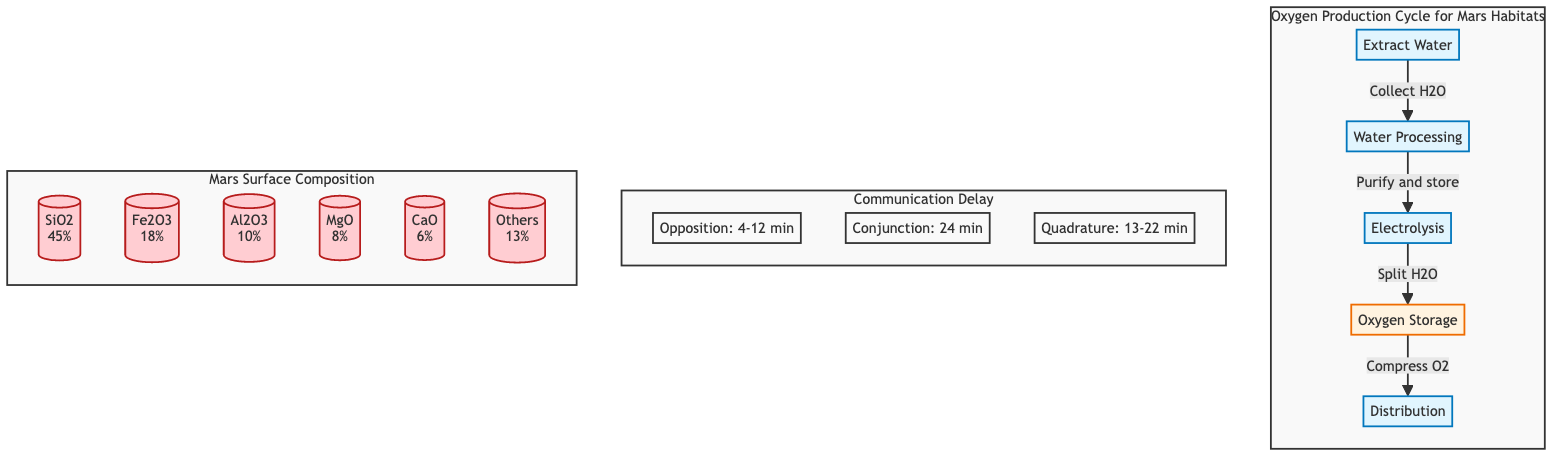What is the first step in the Oxygen Production Cycle? The first step is "Extract Water" which is the starting point of the cycle, initiating the process of obtaining hydrogen and oxygen.
Answer: Extract Water How many processes are involved in the Oxygen Production Cycle for Mars Habitats? There are four main processes; they are "Water Processing," "Electrolysis," "Oxygen Storage," and "Distribution."
Answer: 4 What is the output of the "Electrolysis" node? The output of the "Electrolysis" node is the splitting of H2O, which generates oxygen and hydrogen as byproducts because it specifically refers to the division of water into its elemental components.
Answer: Split H2O At what position does "Oxygen Storage" occur in the cycle? "Oxygen Storage" occurs after "Electrolysis," as indicated by the arrow directing the flow from "Electrolysis" to "Oxygen Storage."
Answer: 3rd What is the communication delay during conjunction? The communication delay during conjunction is 24 minutes according to the specified data in the diagram, representing a situation where Mars and Earth are on opposite sides of the sun.
Answer: 24 min How does "Oxygen Storage" relate to "Distribution"? "Oxygen Storage" leads to "Distribution," meaning that after oxygen is stored, it is then compressed and distributed for use, illustrating a direct flow between these two stages in the oxygen production process.
Answer: Leads to Which mineral has the highest proportion in Mars Surface Composition? The mineral with the highest proportion is SiO2 at 45%, as indicated in the pie chart section of the diagram showing the composition of Martian soil samples.
Answer: SiO2 What is the percentage of Fe2O3 in the Mars Surface Composition? The percentage of Fe2O3 is 18%, which states the specific mineral content in the Martian soil samples examined.
Answer: 18% Which segment of the diagram indicates a higher communication delay: opposition or quadrature? The opposition segment indicates a higher communication delay at 4-12 minutes compared to quadrature, which has a maximum delay of 22 minutes.
Answer: Opposition What are the two storage methods involved in the Oxygen Production Cycle? The two storage methods mentioned are "Oxygen Storage" which is about storing the produced oxygen and "Compress O2" which is about the process of compressing the stored oxygen for efficient distribution.
Answer: Oxygen Storage, Compress O2 